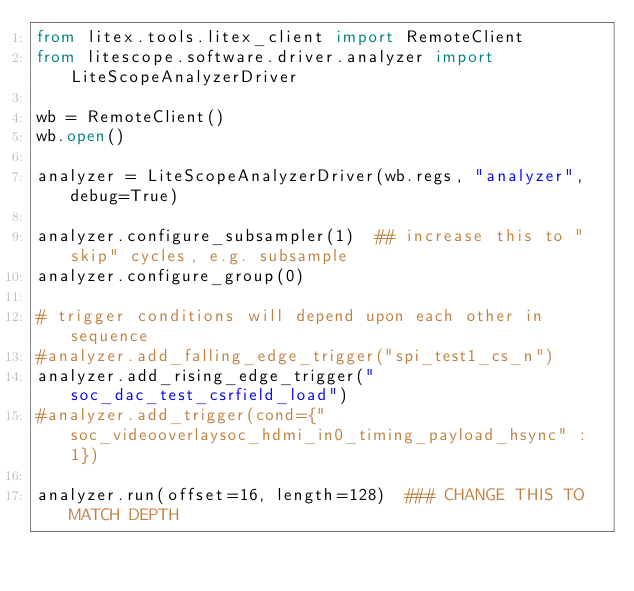<code> <loc_0><loc_0><loc_500><loc_500><_Python_>from litex.tools.litex_client import RemoteClient
from litescope.software.driver.analyzer import LiteScopeAnalyzerDriver

wb = RemoteClient()
wb.open()

analyzer = LiteScopeAnalyzerDriver(wb.regs, "analyzer", debug=True)

analyzer.configure_subsampler(1)  ## increase this to "skip" cycles, e.g. subsample
analyzer.configure_group(0)

# trigger conditions will depend upon each other in sequence
#analyzer.add_falling_edge_trigger("spi_test1_cs_n")
analyzer.add_rising_edge_trigger("soc_dac_test_csrfield_load")
#analyzer.add_trigger(cond={"soc_videooverlaysoc_hdmi_in0_timing_payload_hsync" : 1}) 

analyzer.run(offset=16, length=128)  ### CHANGE THIS TO MATCH DEPTH</code> 